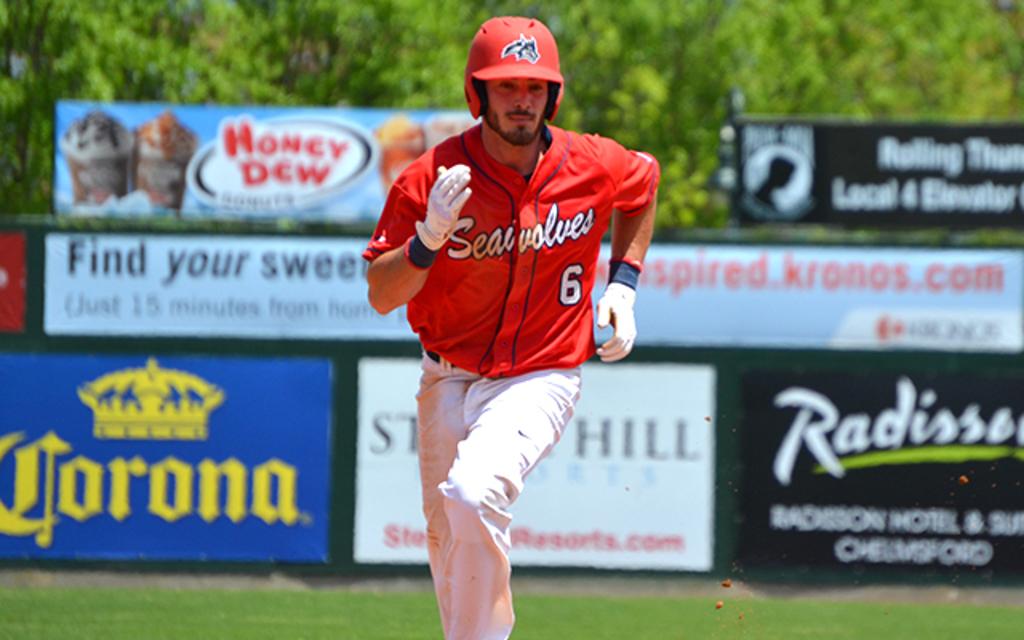What team does the baserunner play for?
Ensure brevity in your answer.  Seawolves. What do the signs say in the back?
Ensure brevity in your answer.  Corona. 